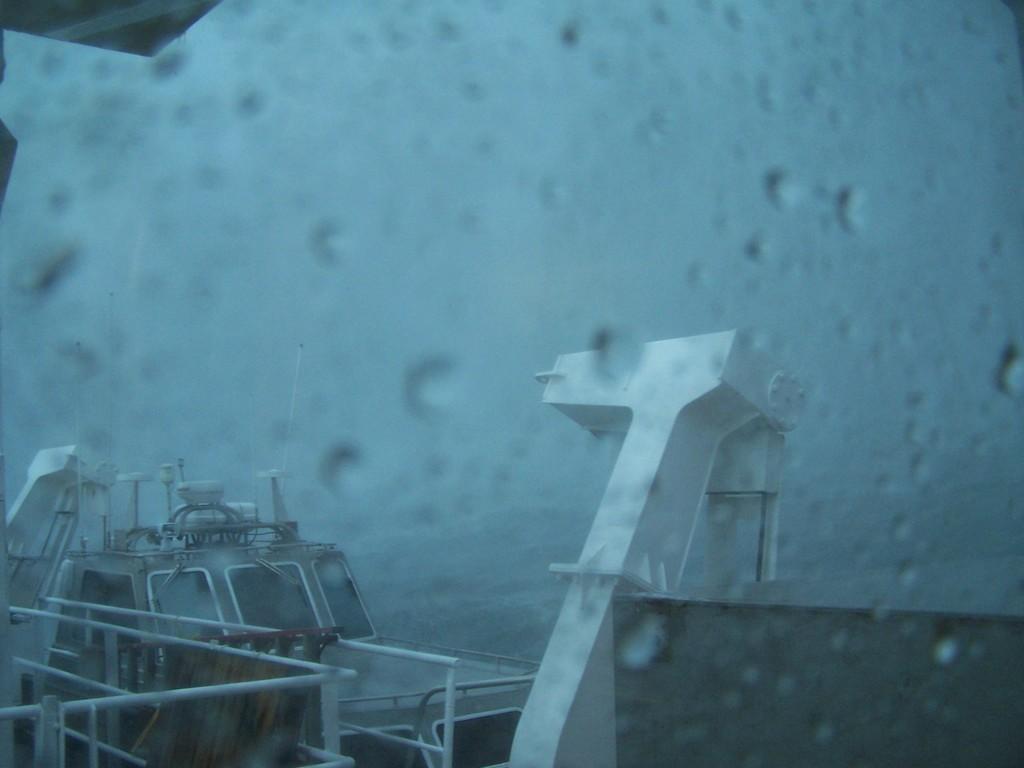Please provide a concise description of this image. In this image we can see ships on the water and sky. 